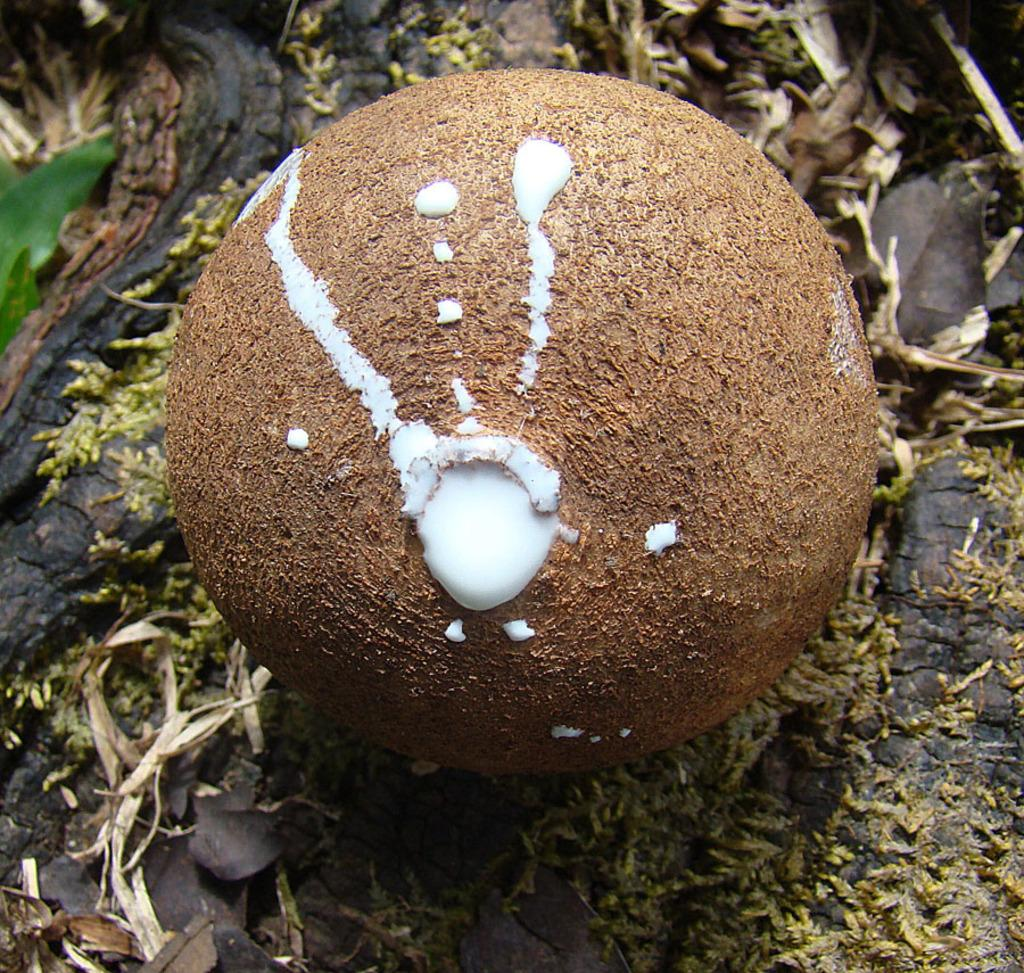What is the main subject of the image? The main subject of the image is an object that resembles a fruit. Where is the fruit-like object located? The fruit-like object is on a tree. What else can be seen around the fruit-like object? There are leaves around the fruit-like object in the image. How does the beggar in the image seek approval from the pail? There is no beggar or pail present in the image; it features a fruit-like object on a tree with leaves around it. 